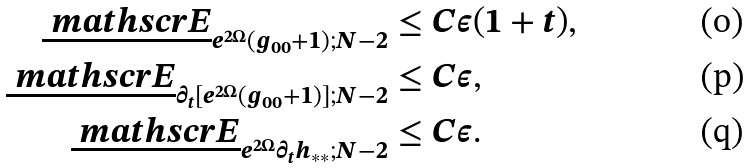<formula> <loc_0><loc_0><loc_500><loc_500>\underline { \ m a t h s c r { E } } _ { e ^ { 2 \Omega } ( g _ { 0 0 } + 1 ) ; N - 2 } & \leq C \epsilon ( 1 + t ) , \\ \underline { \ m a t h s c r { E } } _ { \partial _ { t } [ e ^ { 2 \Omega } ( g _ { 0 0 } + 1 ) ] ; N - 2 } & \leq C \epsilon , \\ \underline { \ m a t h s c r { E } } _ { e ^ { 2 \Omega } \partial _ { t } h _ { * * } ; N - 2 } & \leq C \epsilon .</formula> 